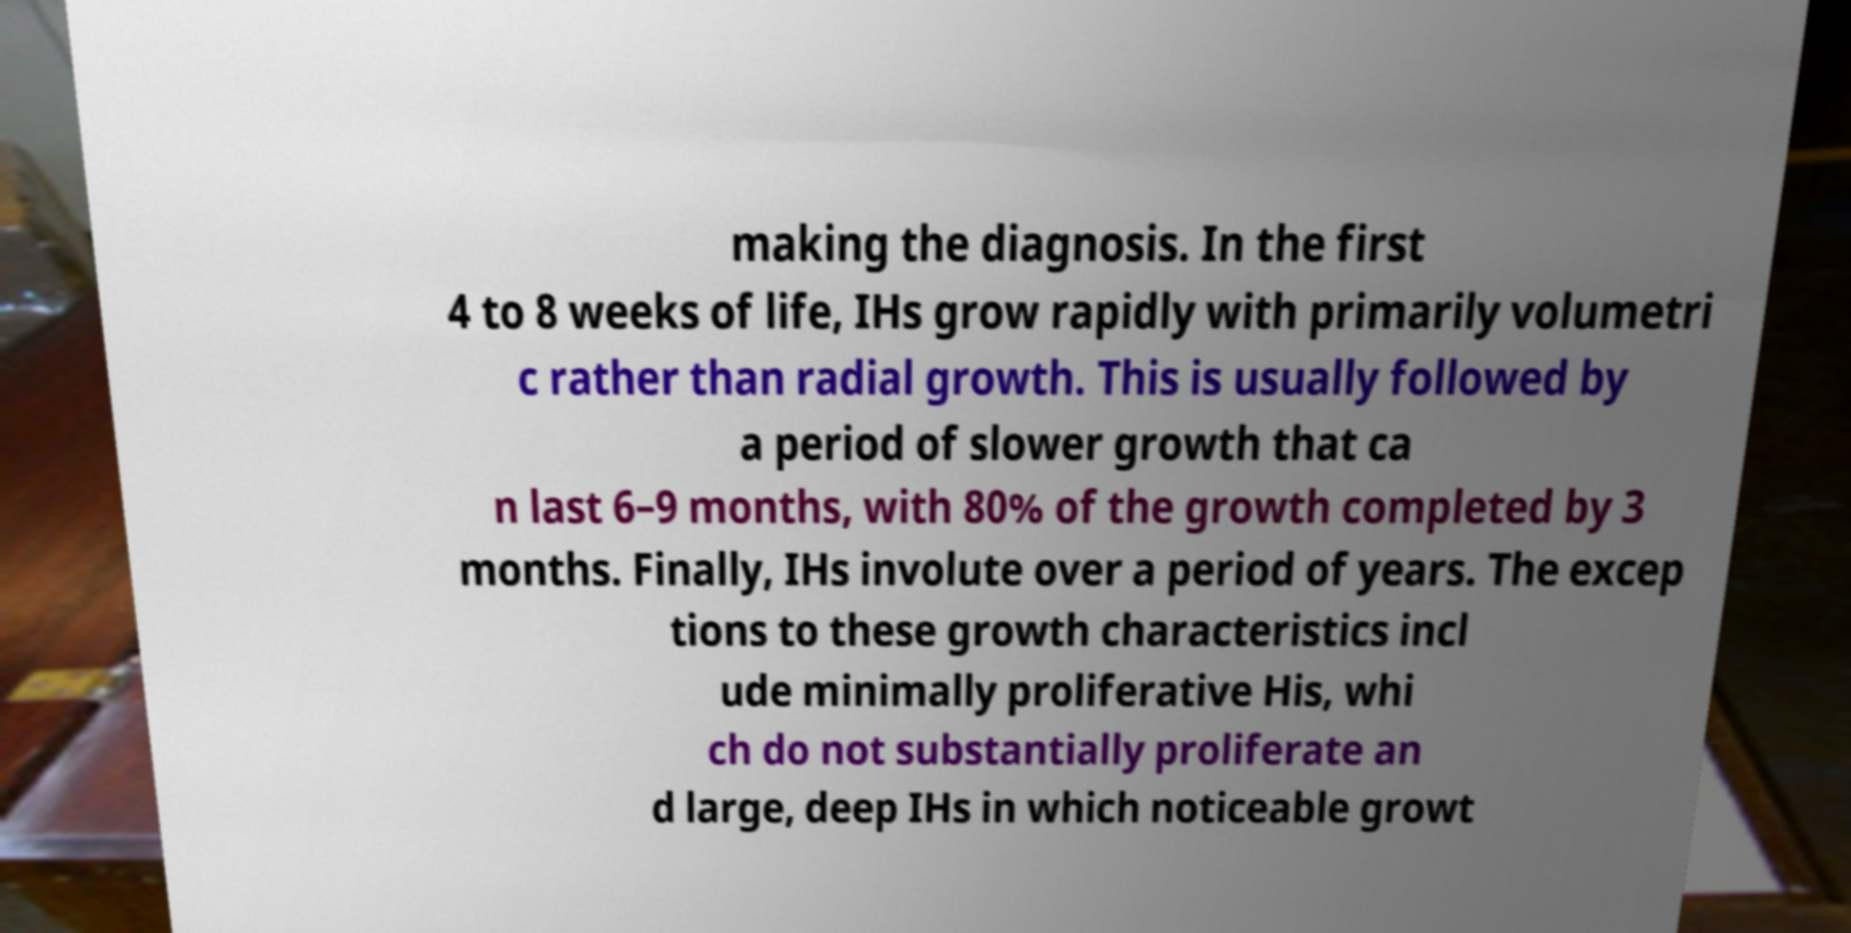Can you accurately transcribe the text from the provided image for me? making the diagnosis. In the first 4 to 8 weeks of life, IHs grow rapidly with primarily volumetri c rather than radial growth. This is usually followed by a period of slower growth that ca n last 6–9 months, with 80% of the growth completed by 3 months. Finally, IHs involute over a period of years. The excep tions to these growth characteristics incl ude minimally proliferative His, whi ch do not substantially proliferate an d large, deep IHs in which noticeable growt 